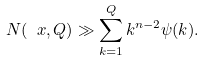Convert formula to latex. <formula><loc_0><loc_0><loc_500><loc_500>N ( \ x , Q ) \gg \sum _ { k = 1 } ^ { Q } k ^ { n - 2 } \psi ( k ) .</formula> 